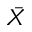Convert formula to latex. <formula><loc_0><loc_0><loc_500><loc_500>\bar { X }</formula> 